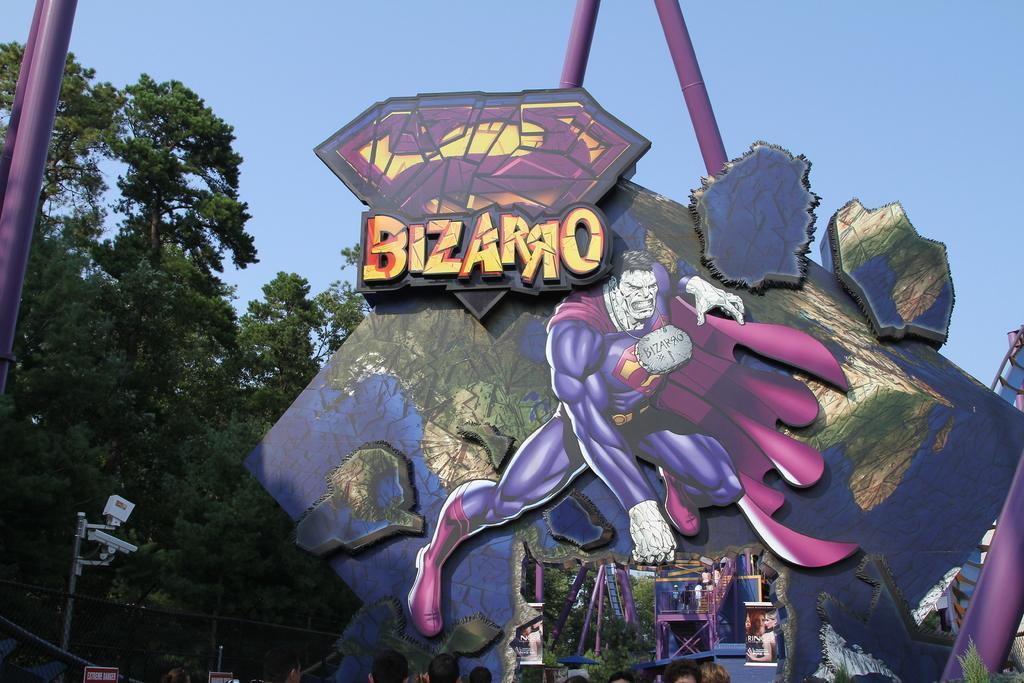Could you give a brief overview of what you see in this image? In this picture we can see a roller coaster, and few people are standing on it, in front of the roller coaster we can find few trees and cameras. 